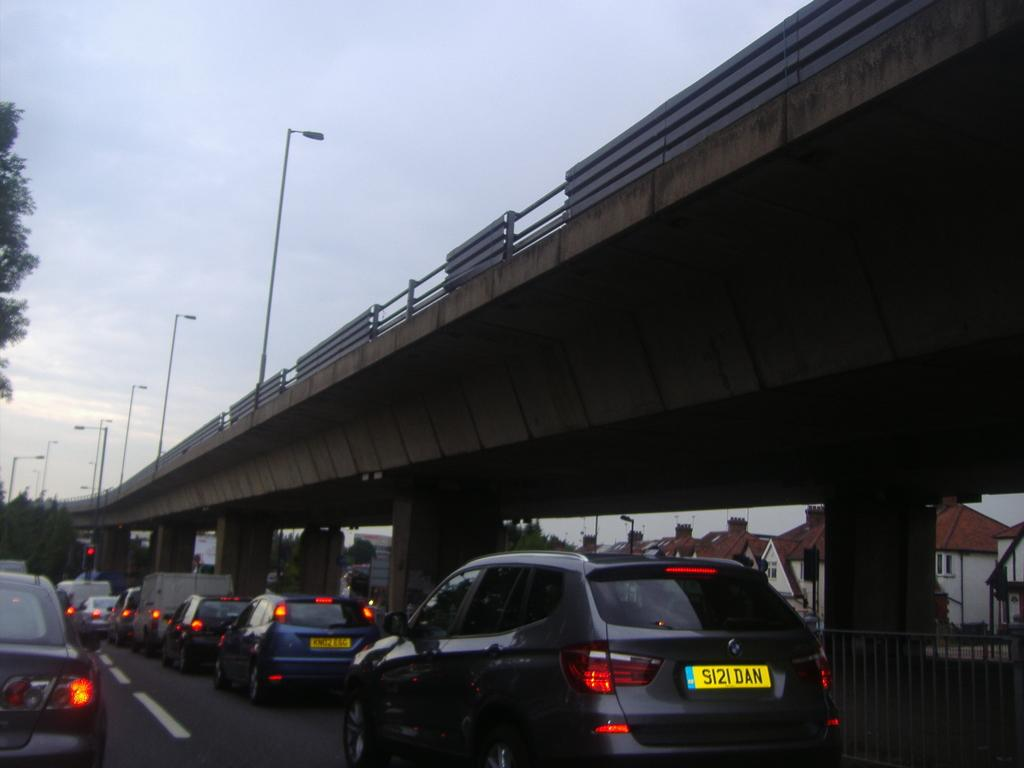What is happening on the road in the image? There are vehicles on the road in the image. Where are the vehicles located in relation to the flyover bridge? The vehicles are under a flyover bridge in the image. What structures can be seen along the road in the image? There are lamp posts in the image. How would you describe the weather or lighting conditions in the image? The sky appears gloomy in the image. What type of stamp is being used by the governor in the image? There is no governor or stamp present in the image. What kind of test is being conducted on the vehicles in the image? There is no test being conducted on the vehicles in the image; they are simply driving on the road. 